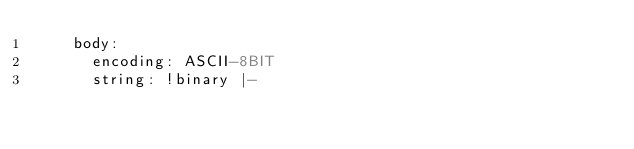<code> <loc_0><loc_0><loc_500><loc_500><_YAML_>    body:
      encoding: ASCII-8BIT
      string: !binary |-</code> 